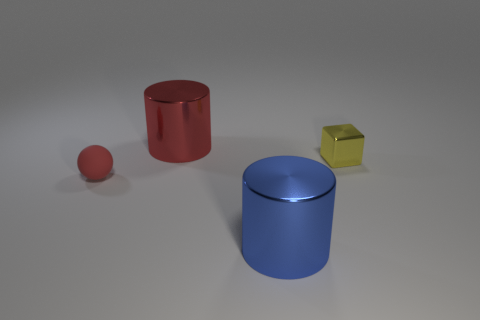What might be the purpose of these objects in a real-world setting? These objects, if they were real, might be containers or geometric models. The cylinders could serve as storage receptacles, while the cube and the sphere might be used as educational tools to teach geometry or as playful objects like dice or a ball. 